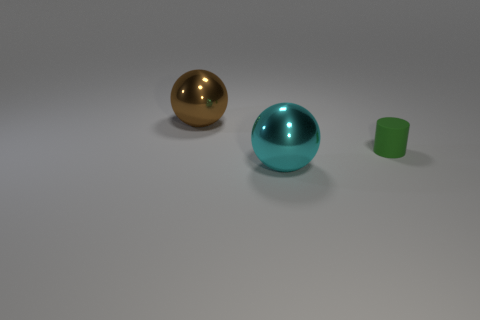Add 3 large green rubber objects. How many objects exist? 6 Subtract all balls. How many objects are left? 1 Add 3 tiny green rubber objects. How many tiny green rubber objects are left? 4 Add 1 tiny cyan objects. How many tiny cyan objects exist? 1 Subtract 0 yellow cylinders. How many objects are left? 3 Subtract all metallic balls. Subtract all tiny cyan metallic blocks. How many objects are left? 1 